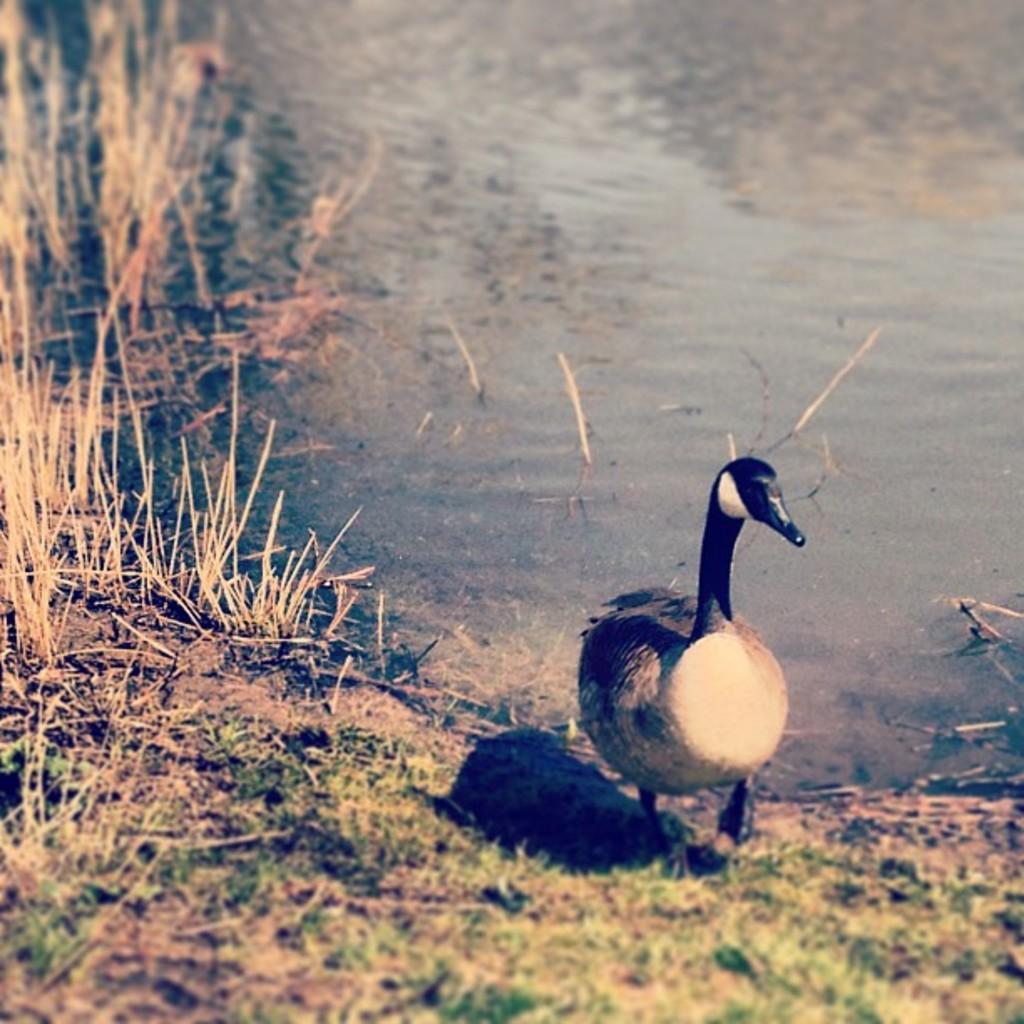In one or two sentences, can you explain what this image depicts? In the right side of the image there is a duck on the land. At the back there is a water and at the left there is a grass. 